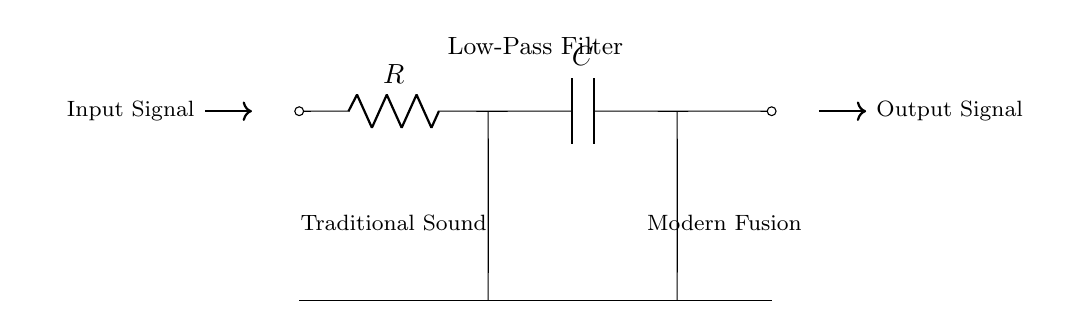What components are used in this circuit? The circuit consists of a resistor and a capacitor, shown with the labels R and C respectively.
Answer: Resistor and Capacitor What does this circuit represent? This circuit represents a low-pass filter, indicated by the label in the circuit diagram, which allows low-frequency signals to pass while attenuating higher frequencies.
Answer: Low-Pass Filter What is the input type for this circuit? The input type indicated in the circuit is "Input Signal," which implies that the circuit receives sound or audio input to process.
Answer: Input Signal What is the purpose of the capacitor in this circuit? The capacitor in a low-pass filter circuit stores charge and determines the cutoff frequency, affecting how fast the circuit responds to changes in the input signal.
Answer: Charge Storage How does the resistor affect the filtering process? The resistor controls the amount of current flowing in the circuit and, in combination with the capacitor, sets the time constant for the circuit, ultimately influencing the cutoff frequency of the low-pass filter.
Answer: Controls Current At what point is the output taken from the circuit? The output is taken from the circuit after the capacitor at the rightmost point, shown by the arrow indicating the output signal path.
Answer: After the Capacitor 